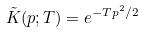<formula> <loc_0><loc_0><loc_500><loc_500>\tilde { K } ( p ; T ) = e ^ { - T p ^ { 2 } / 2 }</formula> 